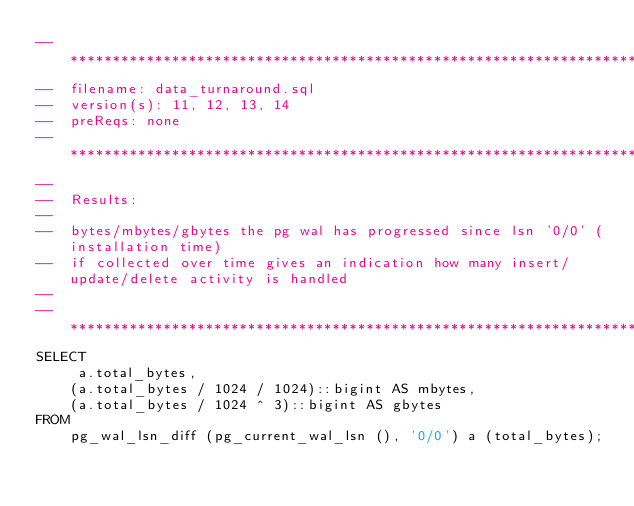Convert code to text. <code><loc_0><loc_0><loc_500><loc_500><_SQL_>-- ********************************************************************************************************
--  filename: data_turnaround.sql
--  version(s): 11, 12, 13, 14
--  preReqs: none 
-- ********************************************************************************************************
--
--  Results:
--
--  bytes/mbytes/gbytes the pg wal has progressed since lsn '0/0' (installation time)
--  if collected over time gives an indication how many insert/update/delete activity is handled
--
-- ********************************************************************************************************
SELECT
     a.total_bytes,
    (a.total_bytes / 1024 / 1024)::bigint AS mbytes,
    (a.total_bytes / 1024 ^ 3)::bigint AS gbytes
FROM
    pg_wal_lsn_diff (pg_current_wal_lsn (), '0/0') a (total_bytes);
</code> 